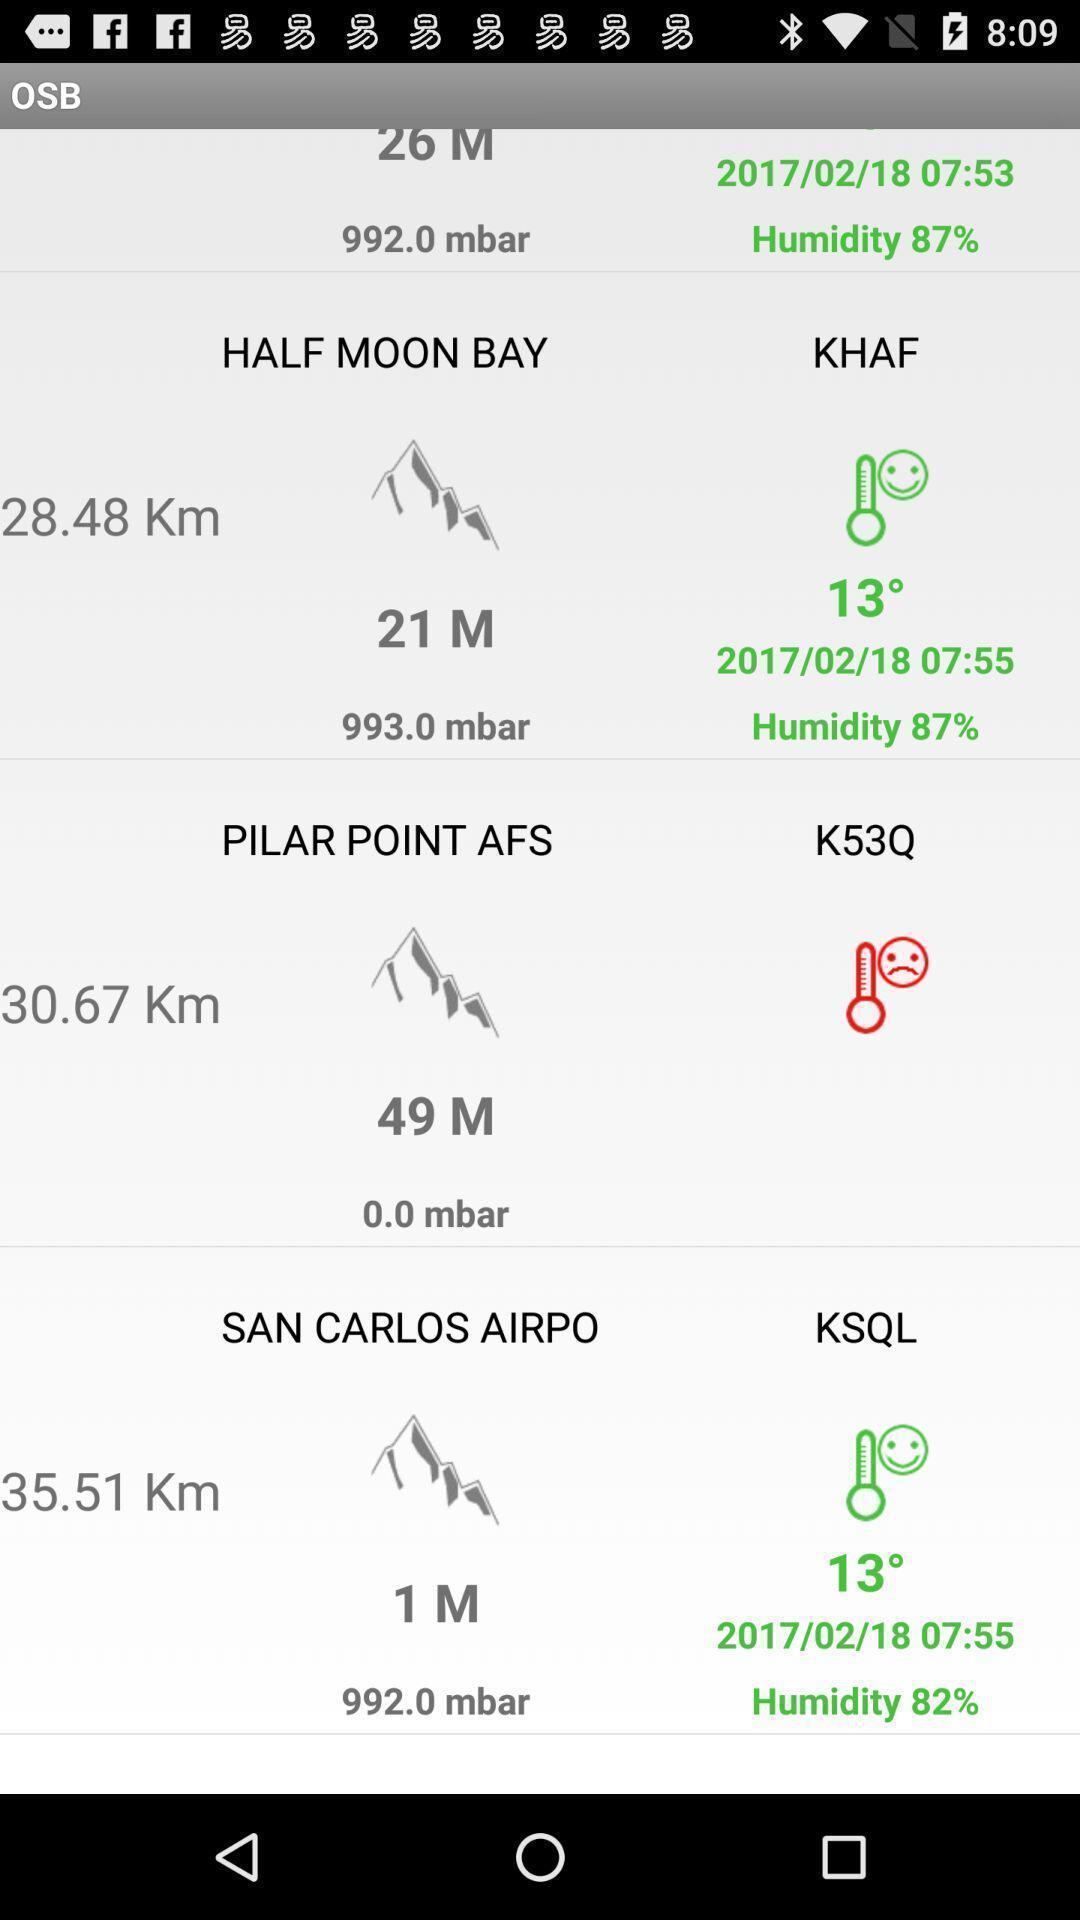Describe the visual elements of this screenshot. Screen displaying weather details. 